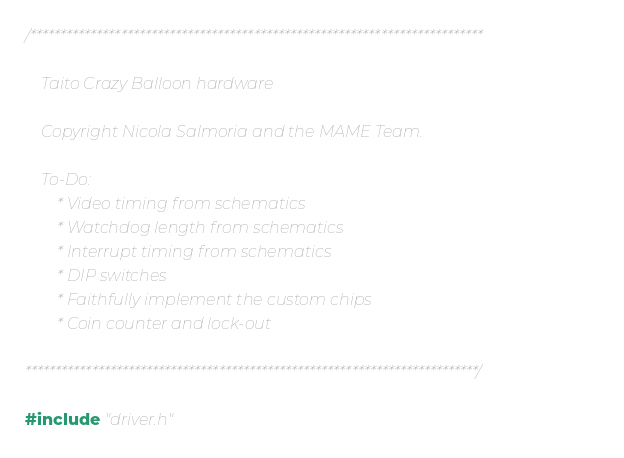<code> <loc_0><loc_0><loc_500><loc_500><_C_>/***************************************************************************

    Taito Crazy Balloon hardware

    Copyright Nicola Salmoria and the MAME Team.

    To-Do:
        * Video timing from schematics
        * Watchdog length from schematics
        * Interrupt timing from schematics
        * DIP switches
        * Faithfully implement the custom chips
        * Coin counter and lock-out

***************************************************************************/

#include "driver.h"</code> 